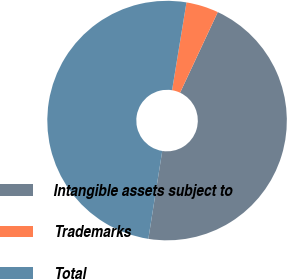Convert chart. <chart><loc_0><loc_0><loc_500><loc_500><pie_chart><fcel>Intangible assets subject to<fcel>Trademarks<fcel>Total<nl><fcel>45.54%<fcel>4.37%<fcel>50.09%<nl></chart> 